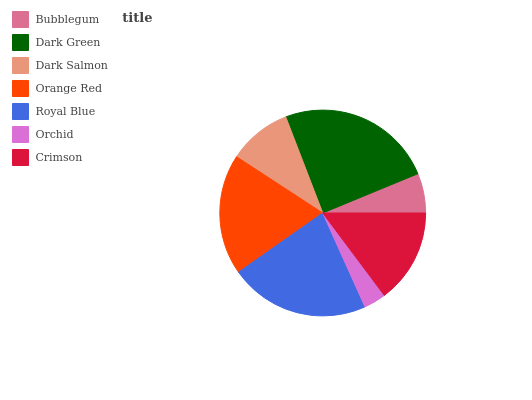Is Orchid the minimum?
Answer yes or no. Yes. Is Dark Green the maximum?
Answer yes or no. Yes. Is Dark Salmon the minimum?
Answer yes or no. No. Is Dark Salmon the maximum?
Answer yes or no. No. Is Dark Green greater than Dark Salmon?
Answer yes or no. Yes. Is Dark Salmon less than Dark Green?
Answer yes or no. Yes. Is Dark Salmon greater than Dark Green?
Answer yes or no. No. Is Dark Green less than Dark Salmon?
Answer yes or no. No. Is Crimson the high median?
Answer yes or no. Yes. Is Crimson the low median?
Answer yes or no. Yes. Is Royal Blue the high median?
Answer yes or no. No. Is Orange Red the low median?
Answer yes or no. No. 